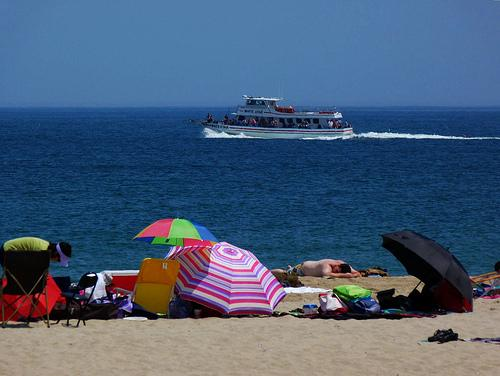Describe what the man laying on the beach is wearing and doing. The man is wearing swim trunks and is sleeping on the beach, while being sunbathed. Provide a short overview of the primary objects that can be found on the sand. On the sand, there are black shoes, a yellow folding beach chair, a black beach chair, and a pale person sunbathing. Briefly describe the general environment of the beach where the umbrellas and other objects are located. The beach environment has a dark blue ocean, beige sandy beach, large colorful umbrellas, and various seating options including chairs. Explain the appearance of the multicolored umbrella and where it is located. The large circular umbrella has red, white, purple, and blue colors and is located on the beige sandy beach. Comment on the state of the sea and its relationship to the boat in the image. The sea is calm, with the boat creating waves as it moves through the dark blue ocean near the sandy beach. Enumerate the colors and shapes of the objects associated with the beach scene. Black (shoes, chair, umbrella), striped (umbrella), yellow (chair), red-white-purple-blue (umbrella), circular (umbrella), multicolored (umbrella). Tell me what kind of boat you see in the image and what it's doing on the water. There's a white boat near the sandy beach, making waves and leaving a wake behind it as it moves through the water. Mention the position and action of the person bending over on the beach. The person wearing a visor and green shirt is leaning down on the beach behind the chair. Mention the key elements seen at the beach and the color of the ocean. Black and striped beach umbrellas, yellow beach chair, man laying on the beach, boat in the ocean, and a dark blue ocean near the beach. What are the significant characteristics of the umbrellas present on the beach? There are black, striped, and multicolored umbrellas, some having circular or unique patterns, providing shade on the beach. 